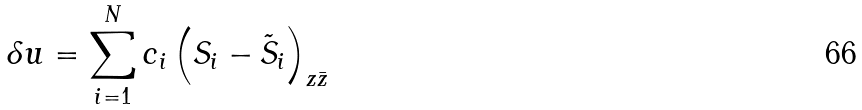<formula> <loc_0><loc_0><loc_500><loc_500>\delta u = \sum _ { i = 1 } ^ { N } c _ { i } \left ( S _ { i } - \tilde { S } _ { i } \right ) _ { z \bar { z } }</formula> 